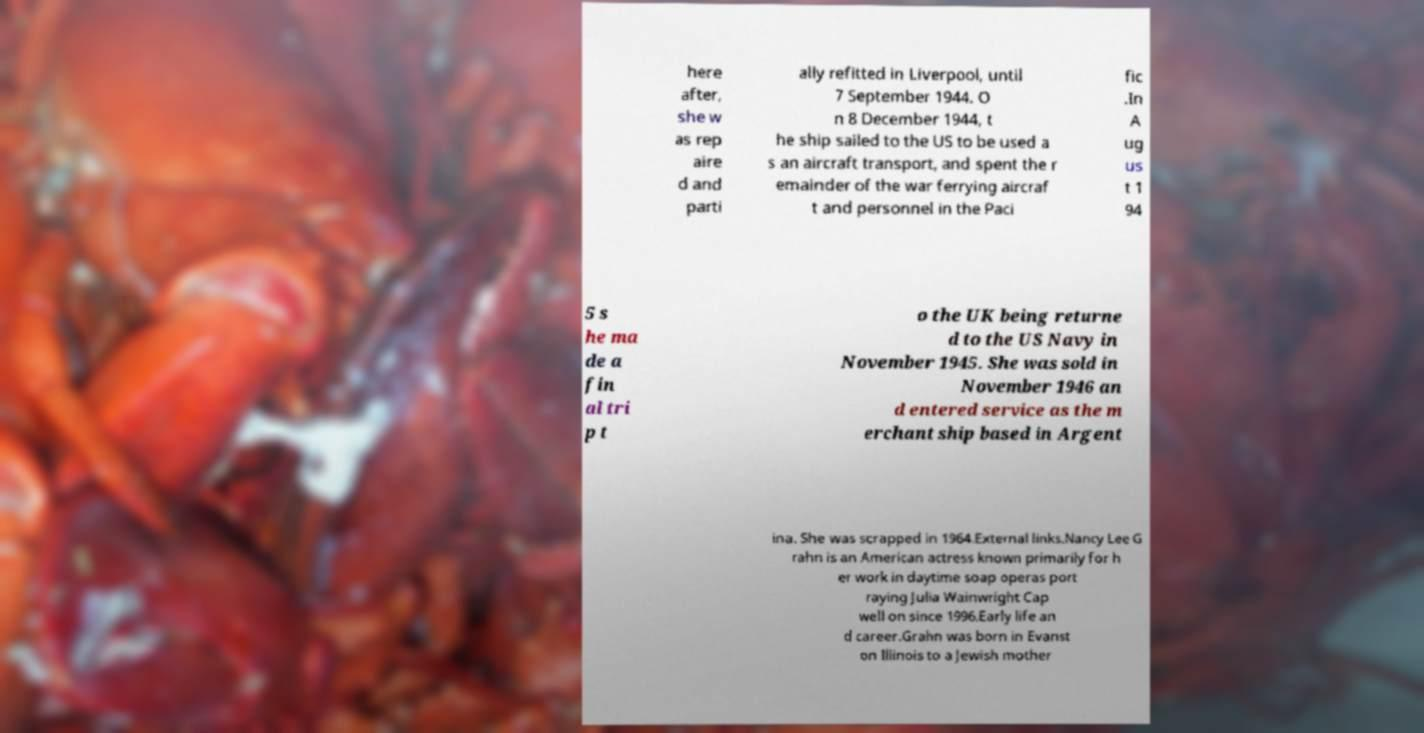I need the written content from this picture converted into text. Can you do that? here after, she w as rep aire d and parti ally refitted in Liverpool, until 7 September 1944. O n 8 December 1944, t he ship sailed to the US to be used a s an aircraft transport, and spent the r emainder of the war ferrying aircraf t and personnel in the Paci fic .In A ug us t 1 94 5 s he ma de a fin al tri p t o the UK being returne d to the US Navy in November 1945. She was sold in November 1946 an d entered service as the m erchant ship based in Argent ina. She was scrapped in 1964.External links.Nancy Lee G rahn is an American actress known primarily for h er work in daytime soap operas port raying Julia Wainwright Cap well on since 1996.Early life an d career.Grahn was born in Evanst on Illinois to a Jewish mother 